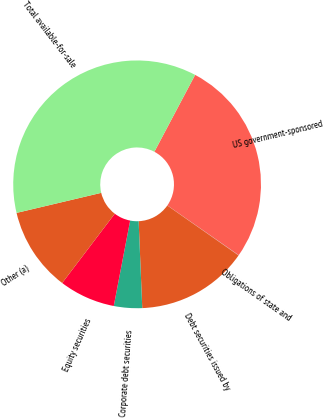Convert chart to OTSL. <chart><loc_0><loc_0><loc_500><loc_500><pie_chart><fcel>US government-sponsored<fcel>Obligations of state and<fcel>Debt securities issued by<fcel>Corporate debt securities<fcel>Equity securities<fcel>Other (a)<fcel>Total available-for-sale<nl><fcel>26.93%<fcel>0.04%<fcel>14.61%<fcel>3.68%<fcel>7.32%<fcel>10.96%<fcel>36.46%<nl></chart> 